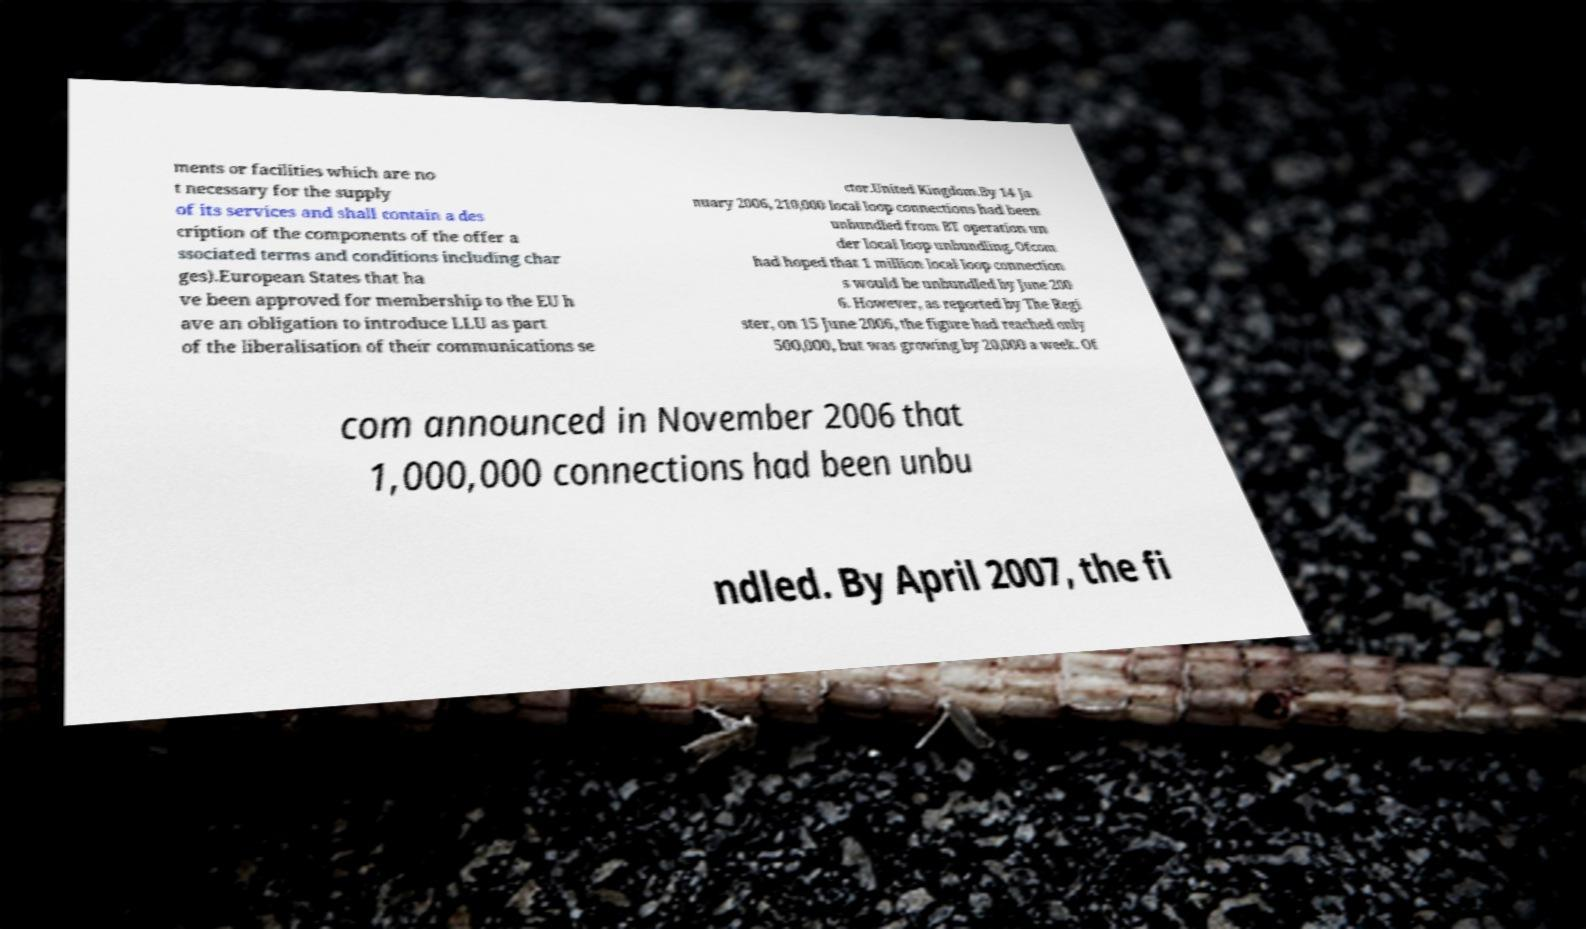Please read and relay the text visible in this image. What does it say? ments or facilities which are no t necessary for the supply of its services and shall contain a des cription of the components of the offer a ssociated terms and conditions including char ges).European States that ha ve been approved for membership to the EU h ave an obligation to introduce LLU as part of the liberalisation of their communications se ctor.United Kingdom.By 14 Ja nuary 2006, 210,000 local loop connections had been unbundled from BT operation un der local loop unbundling. Ofcom had hoped that 1 million local loop connection s would be unbundled by June 200 6. However, as reported by The Regi ster, on 15 June 2006, the figure had reached only 500,000, but was growing by 20,000 a week. Of com announced in November 2006 that 1,000,000 connections had been unbu ndled. By April 2007, the fi 